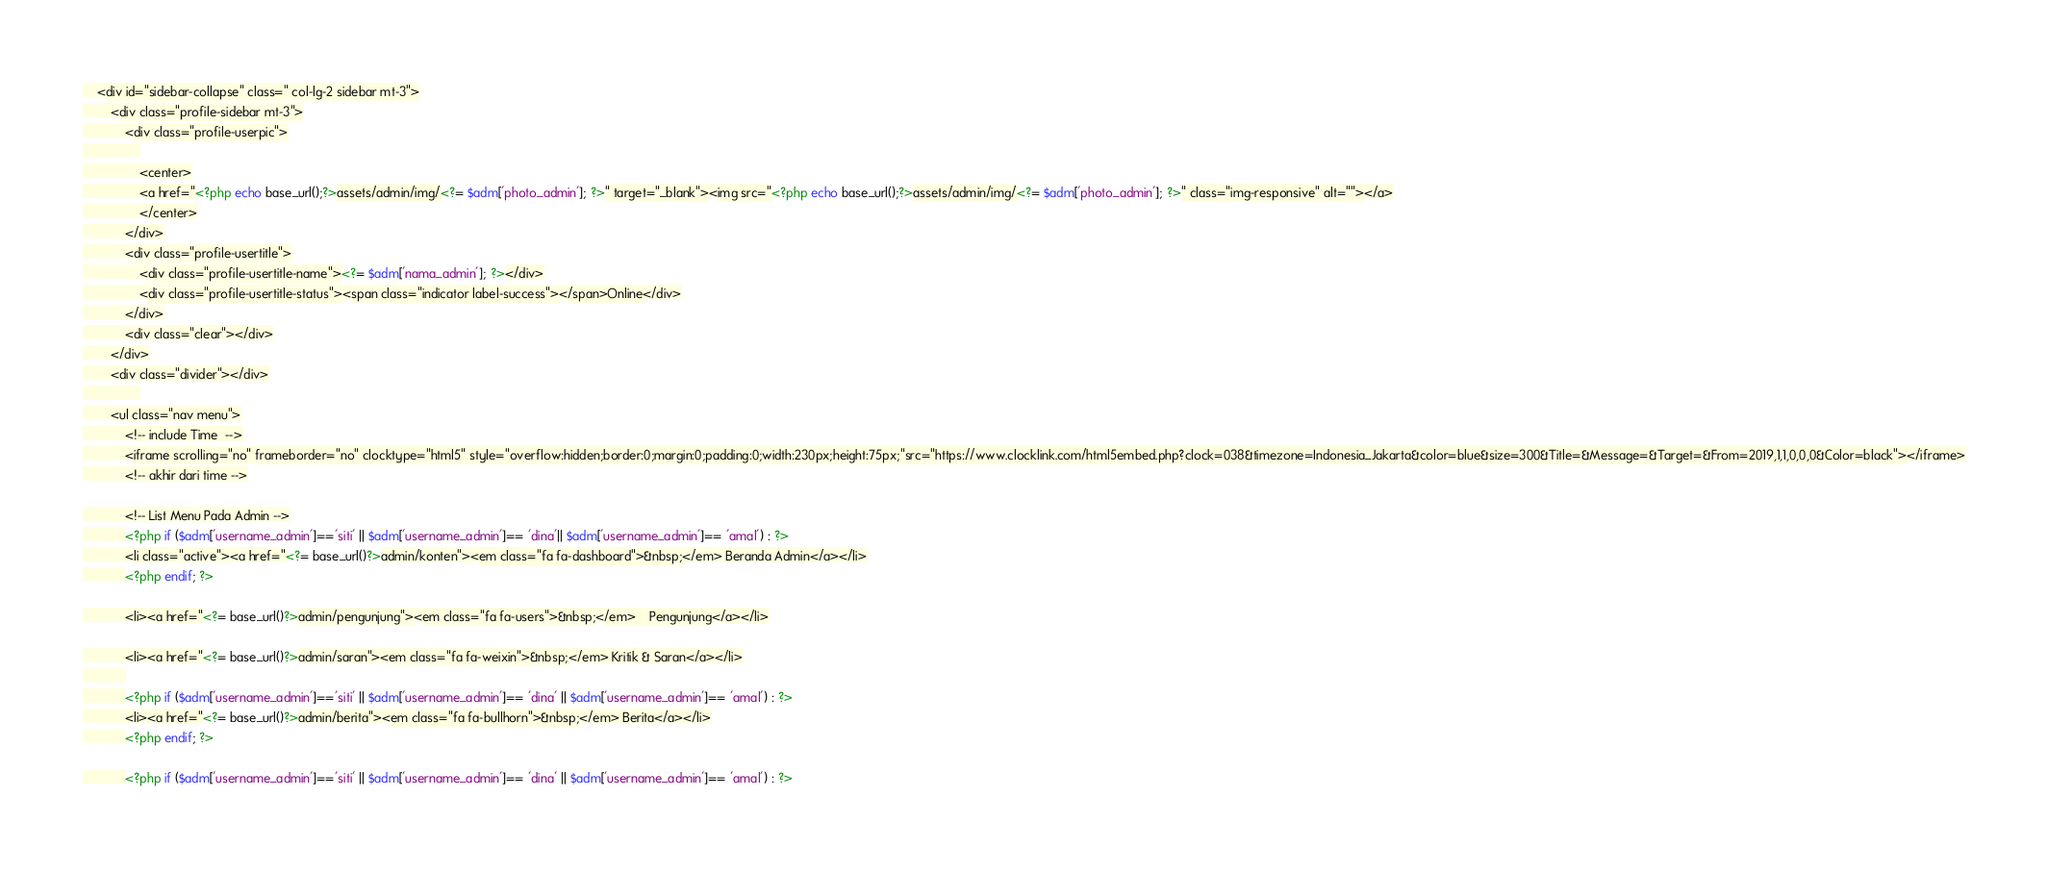<code> <loc_0><loc_0><loc_500><loc_500><_PHP_>	<div id="sidebar-collapse" class=" col-lg-2 sidebar mt-3">
		<div class="profile-sidebar mt-3">
			<div class="profile-userpic">
				
				<center>
				<a href="<?php echo base_url();?>assets/admin/img/<?= $adm['photo_admin']; ?>" target="_blank"><img src="<?php echo base_url();?>assets/admin/img/<?= $adm['photo_admin']; ?>" class="img-responsive" alt=""></a>
				</center>
			</div>
			<div class="profile-usertitle">
				<div class="profile-usertitle-name"><?= $adm['nama_admin']; ?></div>
				<div class="profile-usertitle-status"><span class="indicator label-success"></span>Online</div>
			</div>
			<div class="clear"></div>
		</div>
		<div class="divider"></div>
				
		<ul class="nav menu">
			<!-- include Time  -->
			<iframe scrolling="no" frameborder="no" clocktype="html5" style="overflow:hidden;border:0;margin:0;padding:0;width:230px;height:75px;"src="https://www.clocklink.com/html5embed.php?clock=038&timezone=Indonesia_Jakarta&color=blue&size=300&Title=&Message=&Target=&From=2019,1,1,0,0,0&Color=black"></iframe>
			<!-- akhir dari time -->

			<!-- List Menu Pada Admin -->
			<?php if ($adm['username_admin']=='siti' || $adm['username_admin']== 'dina'|| $adm['username_admin']== 'amal') : ?>
			<li class="active"><a href="<?= base_url()?>admin/konten"><em class="fa fa-dashboard">&nbsp;</em> Beranda Admin</a></li>
			<?php endif; ?>

			<li><a href="<?= base_url()?>admin/pengunjung"><em class="fa fa-users">&nbsp;</em> 	Pengunjung</a></li>

			<li><a href="<?= base_url()?>admin/saran"><em class="fa fa-weixin">&nbsp;</em> Kritik & Saran</a></li>
			
			<?php if ($adm['username_admin']=='siti' || $adm['username_admin']== 'dina' || $adm['username_admin']== 'amal') : ?>
			<li><a href="<?= base_url()?>admin/berita"><em class="fa fa-bullhorn">&nbsp;</em> Berita</a></li>
			<?php endif; ?>

			<?php if ($adm['username_admin']=='siti' || $adm['username_admin']== 'dina' || $adm['username_admin']== 'amal') : ?></code> 